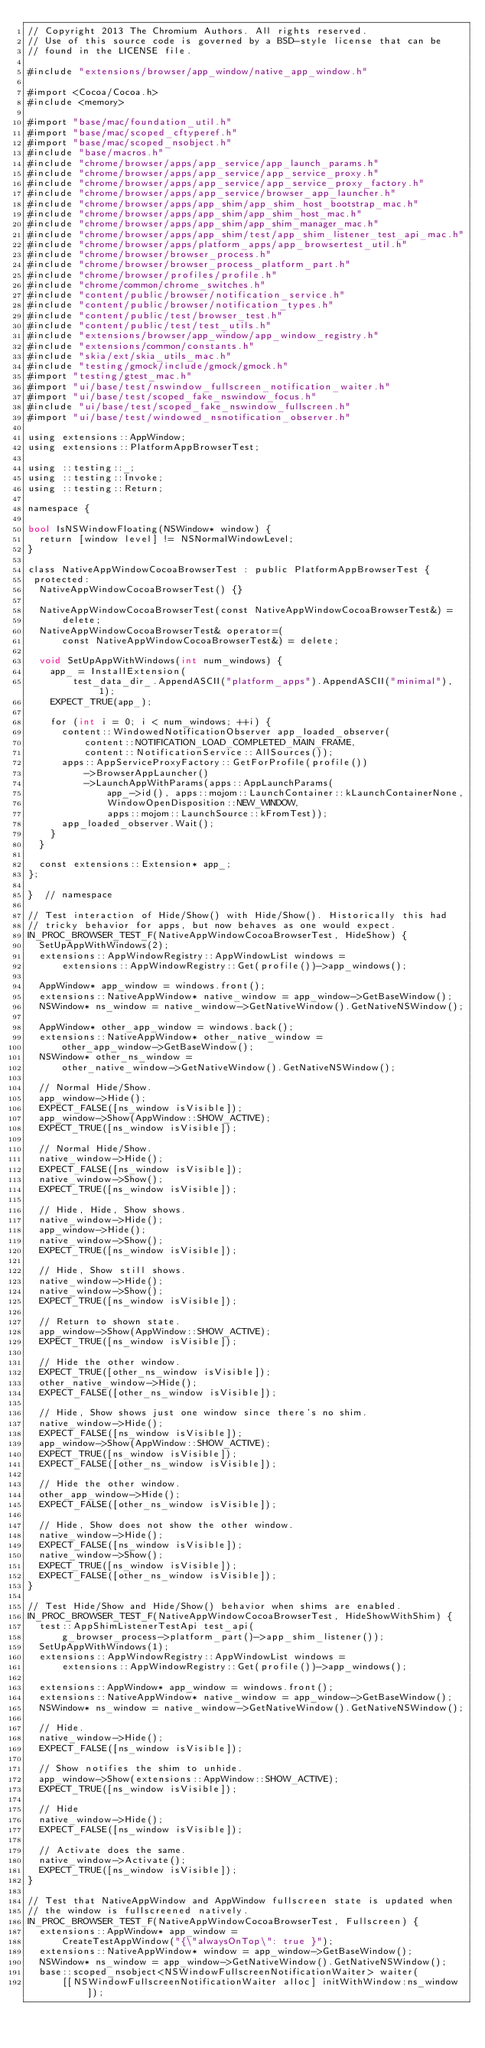<code> <loc_0><loc_0><loc_500><loc_500><_ObjectiveC_>// Copyright 2013 The Chromium Authors. All rights reserved.
// Use of this source code is governed by a BSD-style license that can be
// found in the LICENSE file.

#include "extensions/browser/app_window/native_app_window.h"

#import <Cocoa/Cocoa.h>
#include <memory>

#import "base/mac/foundation_util.h"
#import "base/mac/scoped_cftyperef.h"
#import "base/mac/scoped_nsobject.h"
#include "base/macros.h"
#include "chrome/browser/apps/app_service/app_launch_params.h"
#include "chrome/browser/apps/app_service/app_service_proxy.h"
#include "chrome/browser/apps/app_service/app_service_proxy_factory.h"
#include "chrome/browser/apps/app_service/browser_app_launcher.h"
#include "chrome/browser/apps/app_shim/app_shim_host_bootstrap_mac.h"
#include "chrome/browser/apps/app_shim/app_shim_host_mac.h"
#include "chrome/browser/apps/app_shim/app_shim_manager_mac.h"
#include "chrome/browser/apps/app_shim/test/app_shim_listener_test_api_mac.h"
#include "chrome/browser/apps/platform_apps/app_browsertest_util.h"
#include "chrome/browser/browser_process.h"
#include "chrome/browser/browser_process_platform_part.h"
#include "chrome/browser/profiles/profile.h"
#include "chrome/common/chrome_switches.h"
#include "content/public/browser/notification_service.h"
#include "content/public/browser/notification_types.h"
#include "content/public/test/browser_test.h"
#include "content/public/test/test_utils.h"
#include "extensions/browser/app_window/app_window_registry.h"
#include "extensions/common/constants.h"
#include "skia/ext/skia_utils_mac.h"
#include "testing/gmock/include/gmock/gmock.h"
#import "testing/gtest_mac.h"
#import "ui/base/test/nswindow_fullscreen_notification_waiter.h"
#import "ui/base/test/scoped_fake_nswindow_focus.h"
#include "ui/base/test/scoped_fake_nswindow_fullscreen.h"
#import "ui/base/test/windowed_nsnotification_observer.h"

using extensions::AppWindow;
using extensions::PlatformAppBrowserTest;

using ::testing::_;
using ::testing::Invoke;
using ::testing::Return;

namespace {

bool IsNSWindowFloating(NSWindow* window) {
  return [window level] != NSNormalWindowLevel;
}

class NativeAppWindowCocoaBrowserTest : public PlatformAppBrowserTest {
 protected:
  NativeAppWindowCocoaBrowserTest() {}

  NativeAppWindowCocoaBrowserTest(const NativeAppWindowCocoaBrowserTest&) =
      delete;
  NativeAppWindowCocoaBrowserTest& operator=(
      const NativeAppWindowCocoaBrowserTest&) = delete;

  void SetUpAppWithWindows(int num_windows) {
    app_ = InstallExtension(
        test_data_dir_.AppendASCII("platform_apps").AppendASCII("minimal"), 1);
    EXPECT_TRUE(app_);

    for (int i = 0; i < num_windows; ++i) {
      content::WindowedNotificationObserver app_loaded_observer(
          content::NOTIFICATION_LOAD_COMPLETED_MAIN_FRAME,
          content::NotificationService::AllSources());
      apps::AppServiceProxyFactory::GetForProfile(profile())
          ->BrowserAppLauncher()
          ->LaunchAppWithParams(apps::AppLaunchParams(
              app_->id(), apps::mojom::LaunchContainer::kLaunchContainerNone,
              WindowOpenDisposition::NEW_WINDOW,
              apps::mojom::LaunchSource::kFromTest));
      app_loaded_observer.Wait();
    }
  }

  const extensions::Extension* app_;
};

}  // namespace

// Test interaction of Hide/Show() with Hide/Show(). Historically this had
// tricky behavior for apps, but now behaves as one would expect.
IN_PROC_BROWSER_TEST_F(NativeAppWindowCocoaBrowserTest, HideShow) {
  SetUpAppWithWindows(2);
  extensions::AppWindowRegistry::AppWindowList windows =
      extensions::AppWindowRegistry::Get(profile())->app_windows();

  AppWindow* app_window = windows.front();
  extensions::NativeAppWindow* native_window = app_window->GetBaseWindow();
  NSWindow* ns_window = native_window->GetNativeWindow().GetNativeNSWindow();

  AppWindow* other_app_window = windows.back();
  extensions::NativeAppWindow* other_native_window =
      other_app_window->GetBaseWindow();
  NSWindow* other_ns_window =
      other_native_window->GetNativeWindow().GetNativeNSWindow();

  // Normal Hide/Show.
  app_window->Hide();
  EXPECT_FALSE([ns_window isVisible]);
  app_window->Show(AppWindow::SHOW_ACTIVE);
  EXPECT_TRUE([ns_window isVisible]);

  // Normal Hide/Show.
  native_window->Hide();
  EXPECT_FALSE([ns_window isVisible]);
  native_window->Show();
  EXPECT_TRUE([ns_window isVisible]);

  // Hide, Hide, Show shows.
  native_window->Hide();
  app_window->Hide();
  native_window->Show();
  EXPECT_TRUE([ns_window isVisible]);

  // Hide, Show still shows.
  native_window->Hide();
  native_window->Show();
  EXPECT_TRUE([ns_window isVisible]);

  // Return to shown state.
  app_window->Show(AppWindow::SHOW_ACTIVE);
  EXPECT_TRUE([ns_window isVisible]);

  // Hide the other window.
  EXPECT_TRUE([other_ns_window isVisible]);
  other_native_window->Hide();
  EXPECT_FALSE([other_ns_window isVisible]);

  // Hide, Show shows just one window since there's no shim.
  native_window->Hide();
  EXPECT_FALSE([ns_window isVisible]);
  app_window->Show(AppWindow::SHOW_ACTIVE);
  EXPECT_TRUE([ns_window isVisible]);
  EXPECT_FALSE([other_ns_window isVisible]);

  // Hide the other window.
  other_app_window->Hide();
  EXPECT_FALSE([other_ns_window isVisible]);

  // Hide, Show does not show the other window.
  native_window->Hide();
  EXPECT_FALSE([ns_window isVisible]);
  native_window->Show();
  EXPECT_TRUE([ns_window isVisible]);
  EXPECT_FALSE([other_ns_window isVisible]);
}

// Test Hide/Show and Hide/Show() behavior when shims are enabled.
IN_PROC_BROWSER_TEST_F(NativeAppWindowCocoaBrowserTest, HideShowWithShim) {
  test::AppShimListenerTestApi test_api(
      g_browser_process->platform_part()->app_shim_listener());
  SetUpAppWithWindows(1);
  extensions::AppWindowRegistry::AppWindowList windows =
      extensions::AppWindowRegistry::Get(profile())->app_windows();

  extensions::AppWindow* app_window = windows.front();
  extensions::NativeAppWindow* native_window = app_window->GetBaseWindow();
  NSWindow* ns_window = native_window->GetNativeWindow().GetNativeNSWindow();

  // Hide.
  native_window->Hide();
  EXPECT_FALSE([ns_window isVisible]);

  // Show notifies the shim to unhide.
  app_window->Show(extensions::AppWindow::SHOW_ACTIVE);
  EXPECT_TRUE([ns_window isVisible]);

  // Hide
  native_window->Hide();
  EXPECT_FALSE([ns_window isVisible]);

  // Activate does the same.
  native_window->Activate();
  EXPECT_TRUE([ns_window isVisible]);
}

// Test that NativeAppWindow and AppWindow fullscreen state is updated when
// the window is fullscreened natively.
IN_PROC_BROWSER_TEST_F(NativeAppWindowCocoaBrowserTest, Fullscreen) {
  extensions::AppWindow* app_window =
      CreateTestAppWindow("{\"alwaysOnTop\": true }");
  extensions::NativeAppWindow* window = app_window->GetBaseWindow();
  NSWindow* ns_window = app_window->GetNativeWindow().GetNativeNSWindow();
  base::scoped_nsobject<NSWindowFullscreenNotificationWaiter> waiter(
      [[NSWindowFullscreenNotificationWaiter alloc] initWithWindow:ns_window]);
</code> 